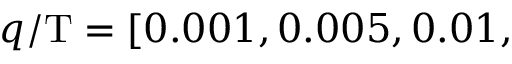Convert formula to latex. <formula><loc_0><loc_0><loc_500><loc_500>q / T = [ 0 . 0 0 1 , 0 . 0 0 5 , 0 . 0 1 ,</formula> 